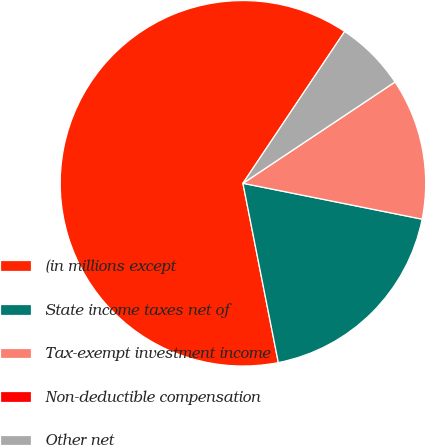<chart> <loc_0><loc_0><loc_500><loc_500><pie_chart><fcel>(in millions except<fcel>State income taxes net of<fcel>Tax-exempt investment income<fcel>Non-deductible compensation<fcel>Other net<nl><fcel>62.49%<fcel>18.75%<fcel>12.5%<fcel>0.0%<fcel>6.25%<nl></chart> 